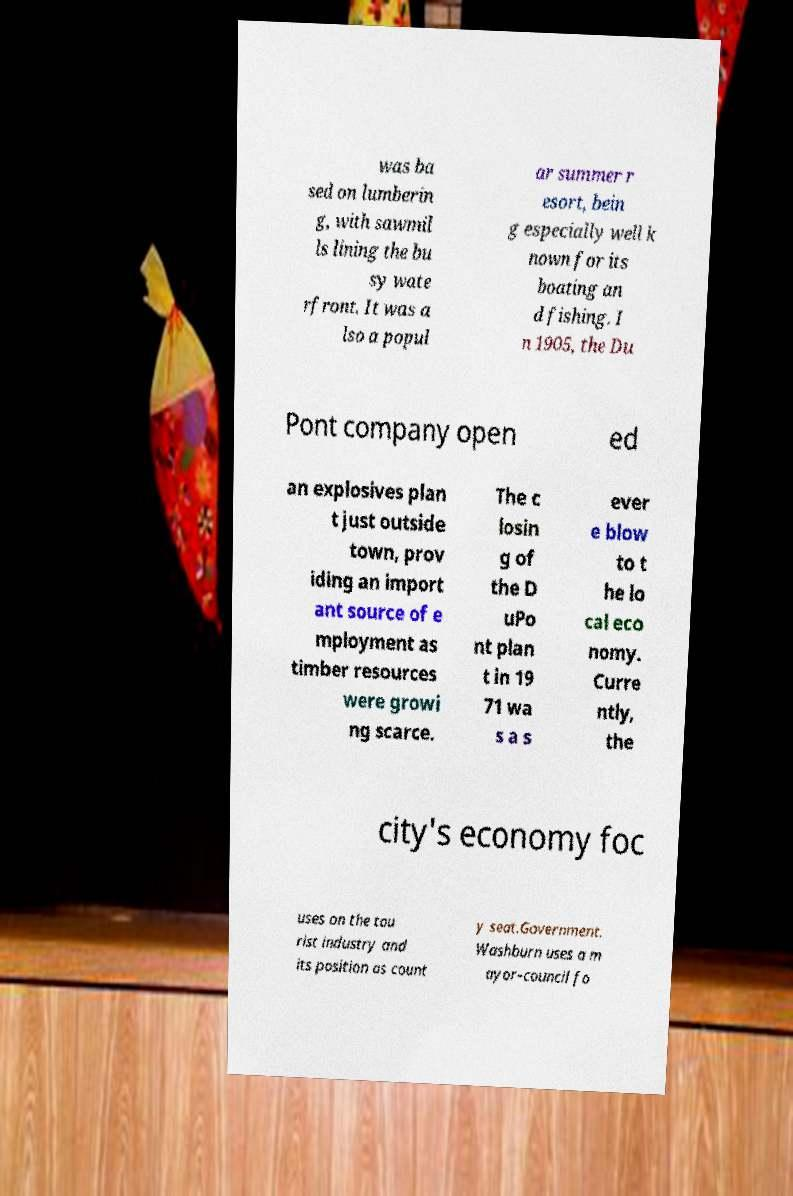What messages or text are displayed in this image? I need them in a readable, typed format. was ba sed on lumberin g, with sawmil ls lining the bu sy wate rfront. It was a lso a popul ar summer r esort, bein g especially well k nown for its boating an d fishing. I n 1905, the Du Pont company open ed an explosives plan t just outside town, prov iding an import ant source of e mployment as timber resources were growi ng scarce. The c losin g of the D uPo nt plan t in 19 71 wa s a s ever e blow to t he lo cal eco nomy. Curre ntly, the city's economy foc uses on the tou rist industry and its position as count y seat.Government. Washburn uses a m ayor–council fo 